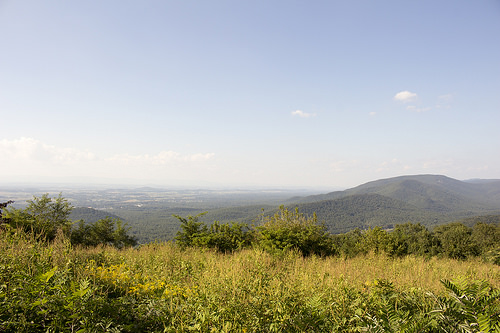<image>
Is the sky behind the mountain? Yes. From this viewpoint, the sky is positioned behind the mountain, with the mountain partially or fully occluding the sky. Is there a sky above the cloud? Yes. The sky is positioned above the cloud in the vertical space, higher up in the scene. 